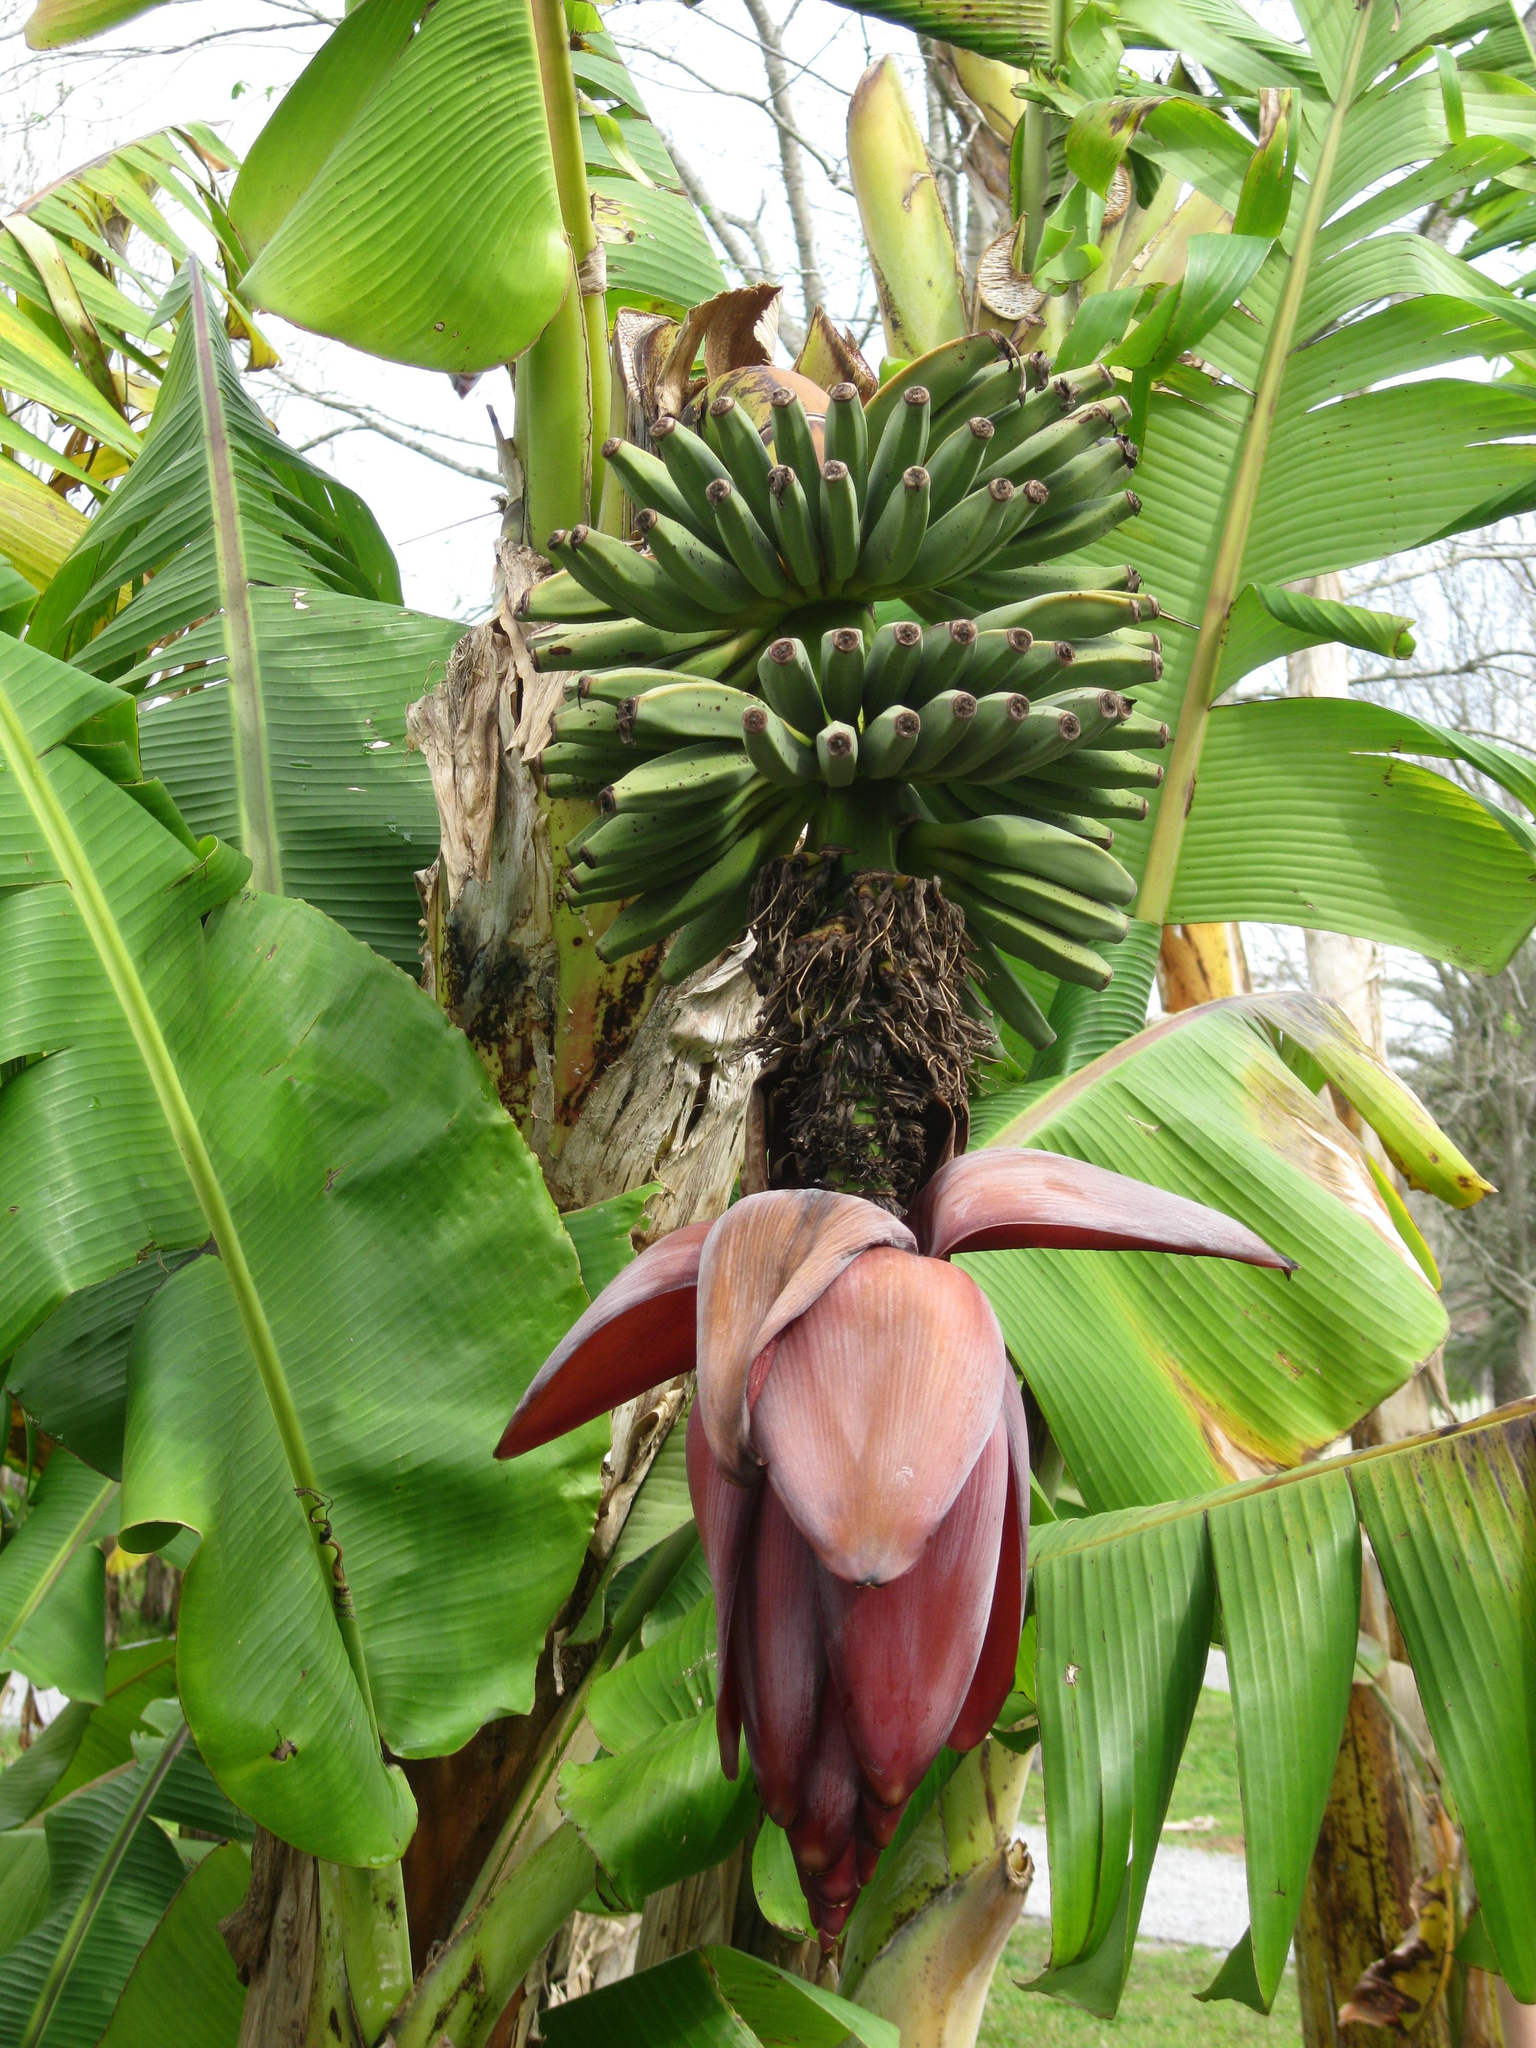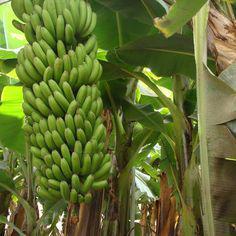The first image is the image on the left, the second image is the image on the right. Examine the images to the left and right. Is the description "The righthand image shows a big purple flower with red underside of a petal visible below a bunch of green bananas, but the left image does not show any red undersides of petals." accurate? Answer yes or no. No. The first image is the image on the left, the second image is the image on the right. Examine the images to the left and right. Is the description "The image to the right is focused on the red flowering bottom of a banana bunch." accurate? Answer yes or no. No. 